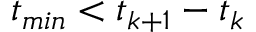Convert formula to latex. <formula><loc_0><loc_0><loc_500><loc_500>t _ { \min } < t _ { k + 1 } - t _ { k }</formula> 